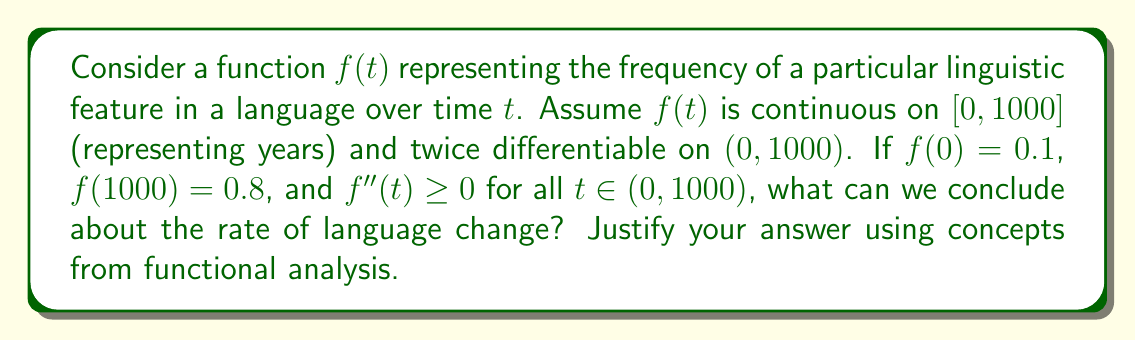Can you solve this math problem? To analyze this problem, we'll use concepts from functional analysis:

1) Continuity: The function $f(t)$ is continuous on $[0, 1000]$, which means the linguistic feature's frequency changes without abrupt jumps over the 1000-year period.

2) Differentiability: $f(t)$ is twice differentiable on $(0, 1000)$, implying that both $f'(t)$ and $f''(t)$ exist. This allows us to analyze the rate and acceleration of change.

3) Mean Value Theorem: Since $f(t)$ is continuous on $[0, 1000]$ and differentiable on $(0, 1000)$, the Mean Value Theorem applies. There exists a $c \in (0, 1000)$ such that:

   $$f'(c) = \frac{f(1000) - f(0)}{1000 - 0} = \frac{0.8 - 0.1}{1000} = 0.0007$$

   This represents the average rate of change over the entire period.

4) Second derivative: Given that $f''(t) \geq 0$ for all $t \in (0, 1000)$, we know that $f(t)$ is convex. This implies that the rate of change $f'(t)$ is non-decreasing.

5) Monotonicity: Since $f''(t) \geq 0$ and $f(1000) > f(0)$, we can conclude that $f'(t) > 0$ for all $t \in (0, 1000)$. This means $f(t)$ is strictly increasing.

Combining these observations, we can conclude that:
a) The linguistic feature's frequency is continuously and monotonically increasing over time.
b) The rate of change is always positive and non-decreasing.
c) The change is accelerating or maintaining a constant rate, but never decelerating.

This analysis suggests a consistent and potentially intensifying trend in the adoption of the linguistic feature over the 1000-year period, rather than a sporadic or declining trend.
Answer: The rate of language change is consistently positive and non-decreasing over the 1000-year period, indicating a continuous and potentially accelerating adoption of the linguistic feature. 